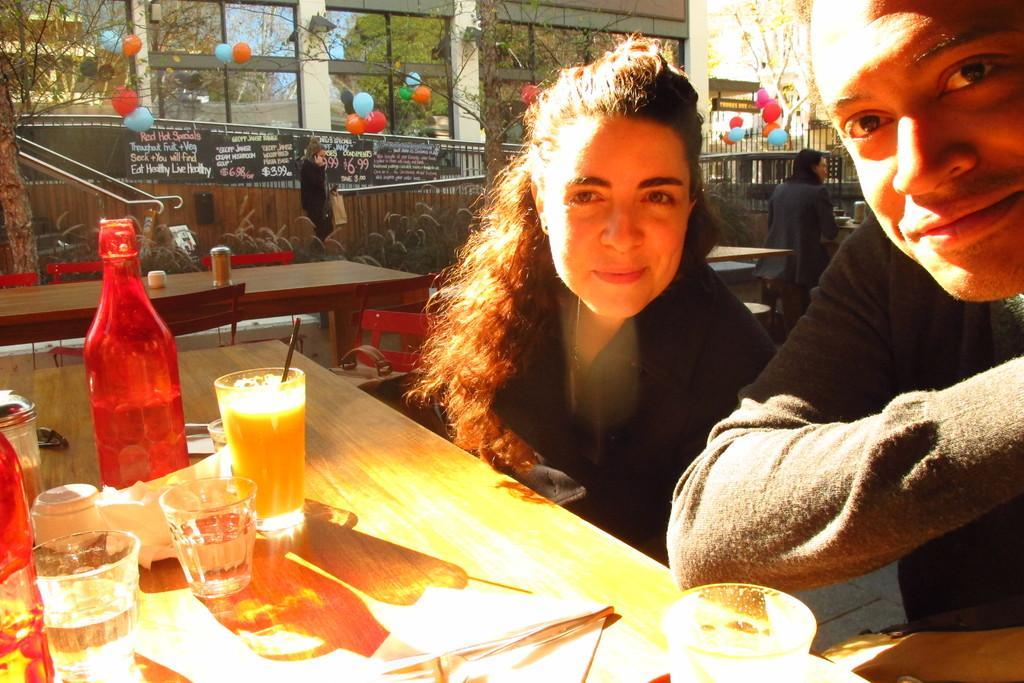Describe this image in one or two sentences. In this picture we can see a man and woman sitting on chair and smiling and in front of them on table we have glass with drink in it, bottle, glasses, tissue paper and in the background we can see wall, building, balloons, trees, fence, some persons. 